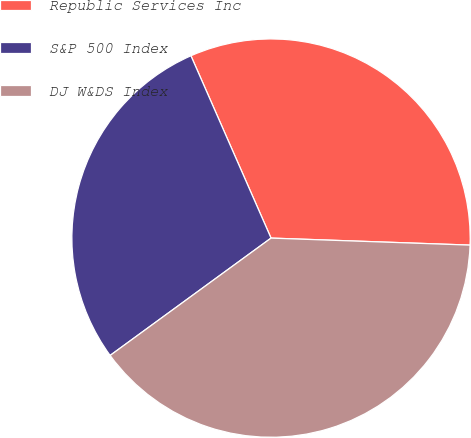Convert chart to OTSL. <chart><loc_0><loc_0><loc_500><loc_500><pie_chart><fcel>Republic Services Inc<fcel>S&P 500 Index<fcel>DJ W&DS Index<nl><fcel>32.15%<fcel>28.44%<fcel>39.41%<nl></chart> 